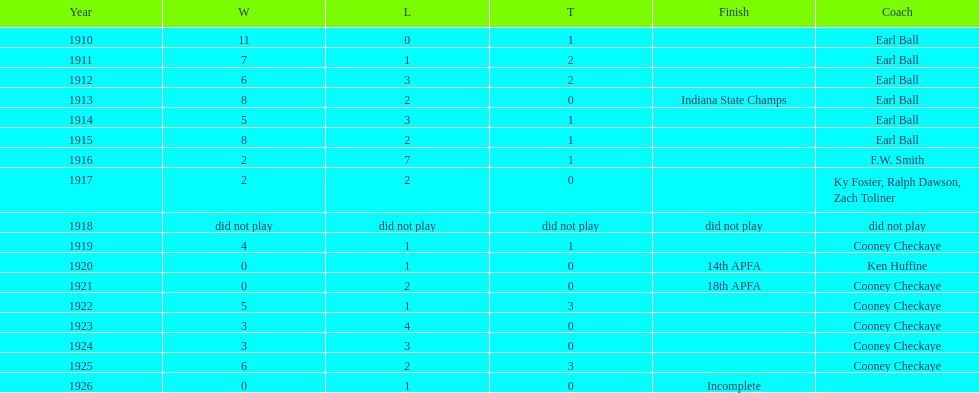How many years did earl ball coach the muncie flyers? 6. 